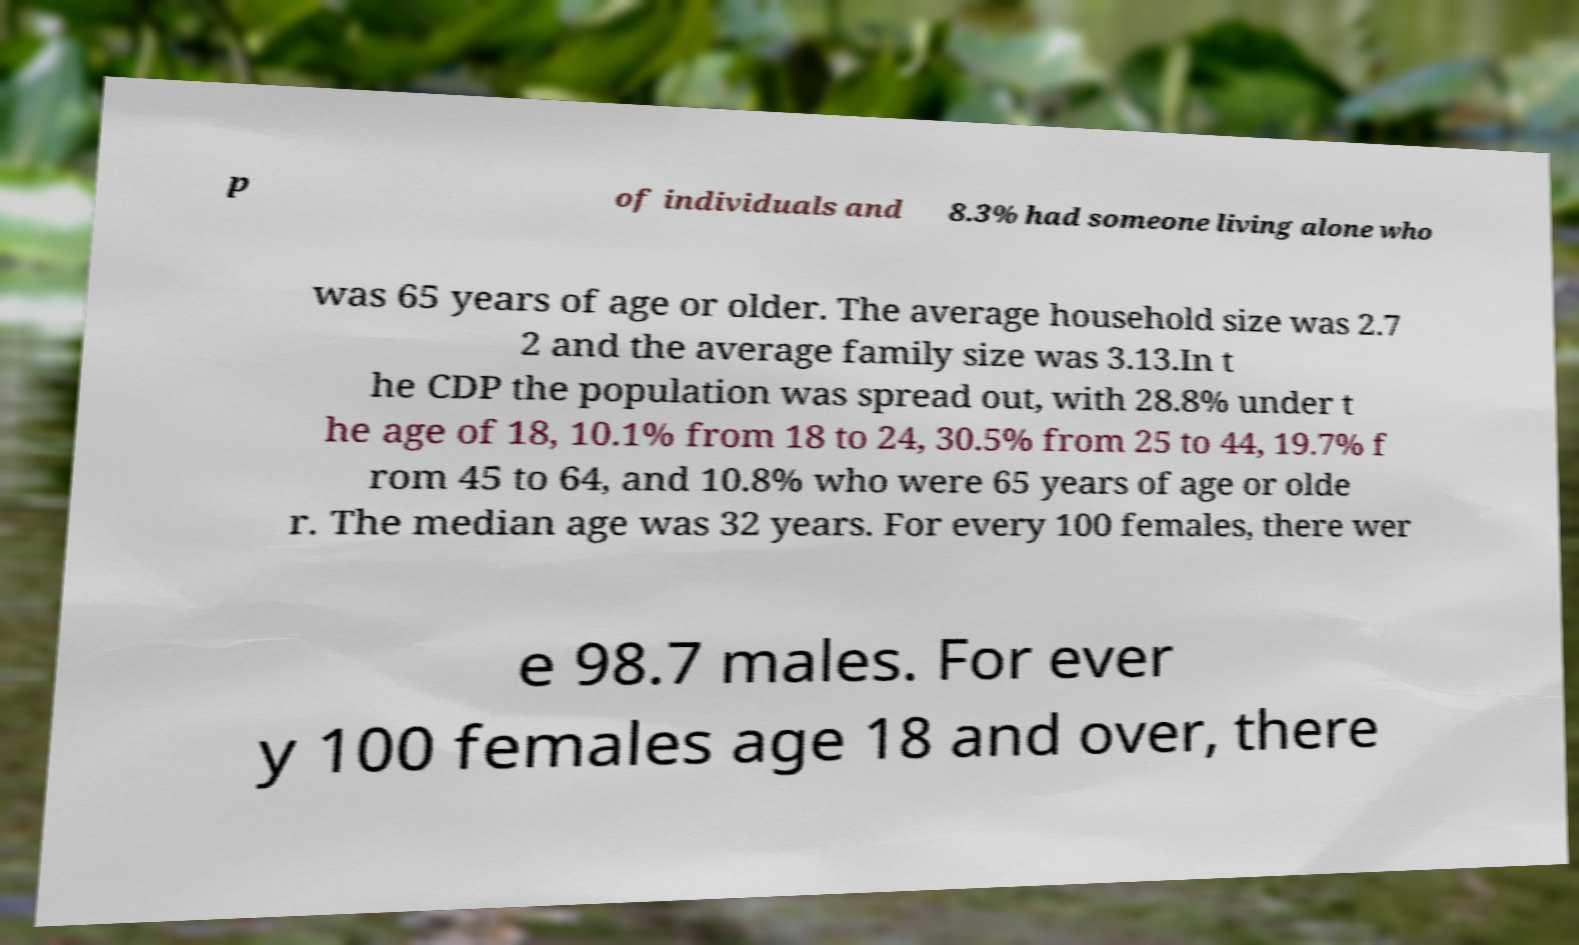Can you accurately transcribe the text from the provided image for me? p of individuals and 8.3% had someone living alone who was 65 years of age or older. The average household size was 2.7 2 and the average family size was 3.13.In t he CDP the population was spread out, with 28.8% under t he age of 18, 10.1% from 18 to 24, 30.5% from 25 to 44, 19.7% f rom 45 to 64, and 10.8% who were 65 years of age or olde r. The median age was 32 years. For every 100 females, there wer e 98.7 males. For ever y 100 females age 18 and over, there 